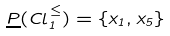Convert formula to latex. <formula><loc_0><loc_0><loc_500><loc_500>\underline { P } ( C l _ { 1 } ^ { \leq } ) = \{ x _ { 1 } , x _ { 5 } \}</formula> 